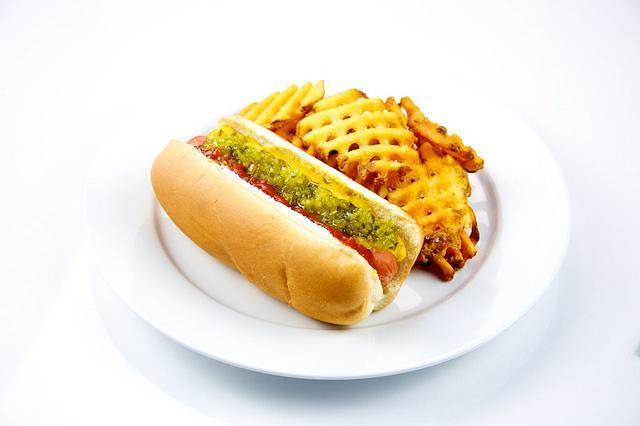How many bears are seen in the photo?
Give a very brief answer. 0. 